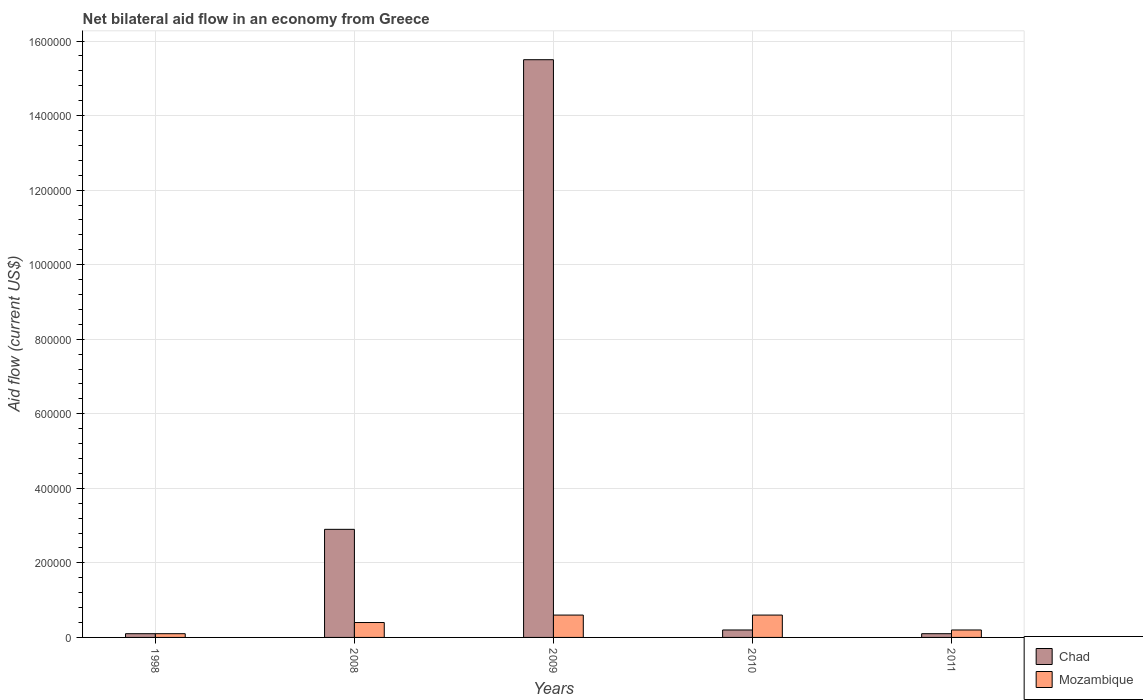How many different coloured bars are there?
Offer a terse response. 2. How many groups of bars are there?
Make the answer very short. 5. Are the number of bars per tick equal to the number of legend labels?
Give a very brief answer. Yes. Are the number of bars on each tick of the X-axis equal?
Provide a succinct answer. Yes. How many bars are there on the 1st tick from the left?
Your answer should be very brief. 2. How many bars are there on the 1st tick from the right?
Provide a succinct answer. 2. What is the label of the 1st group of bars from the left?
Make the answer very short. 1998. In how many cases, is the number of bars for a given year not equal to the number of legend labels?
Ensure brevity in your answer.  0. Across all years, what is the maximum net bilateral aid flow in Mozambique?
Provide a succinct answer. 6.00e+04. Across all years, what is the minimum net bilateral aid flow in Chad?
Offer a terse response. 10000. What is the total net bilateral aid flow in Chad in the graph?
Provide a succinct answer. 1.88e+06. What is the difference between the net bilateral aid flow in Mozambique in 1998 and the net bilateral aid flow in Chad in 2009?
Ensure brevity in your answer.  -1.54e+06. What is the average net bilateral aid flow in Chad per year?
Make the answer very short. 3.76e+05. Is the net bilateral aid flow in Chad in 2010 less than that in 2011?
Offer a very short reply. No. What is the difference between the highest and the second highest net bilateral aid flow in Chad?
Your response must be concise. 1.26e+06. What is the difference between the highest and the lowest net bilateral aid flow in Chad?
Give a very brief answer. 1.54e+06. Is the sum of the net bilateral aid flow in Chad in 1998 and 2011 greater than the maximum net bilateral aid flow in Mozambique across all years?
Your response must be concise. No. What does the 2nd bar from the left in 1998 represents?
Offer a very short reply. Mozambique. What does the 2nd bar from the right in 2010 represents?
Provide a short and direct response. Chad. How many bars are there?
Your answer should be compact. 10. How many years are there in the graph?
Keep it short and to the point. 5. Are the values on the major ticks of Y-axis written in scientific E-notation?
Make the answer very short. No. Does the graph contain any zero values?
Offer a terse response. No. Does the graph contain grids?
Offer a terse response. Yes. Where does the legend appear in the graph?
Give a very brief answer. Bottom right. How many legend labels are there?
Provide a succinct answer. 2. What is the title of the graph?
Provide a succinct answer. Net bilateral aid flow in an economy from Greece. Does "Moldova" appear as one of the legend labels in the graph?
Provide a succinct answer. No. What is the label or title of the Y-axis?
Keep it short and to the point. Aid flow (current US$). What is the Aid flow (current US$) of Chad in 1998?
Ensure brevity in your answer.  10000. What is the Aid flow (current US$) in Mozambique in 1998?
Make the answer very short. 10000. What is the Aid flow (current US$) in Chad in 2008?
Give a very brief answer. 2.90e+05. What is the Aid flow (current US$) of Mozambique in 2008?
Make the answer very short. 4.00e+04. What is the Aid flow (current US$) in Chad in 2009?
Your answer should be compact. 1.55e+06. What is the Aid flow (current US$) in Mozambique in 2009?
Give a very brief answer. 6.00e+04. What is the Aid flow (current US$) in Mozambique in 2011?
Your answer should be compact. 2.00e+04. Across all years, what is the maximum Aid flow (current US$) in Chad?
Your answer should be compact. 1.55e+06. Across all years, what is the maximum Aid flow (current US$) of Mozambique?
Provide a succinct answer. 6.00e+04. Across all years, what is the minimum Aid flow (current US$) in Chad?
Make the answer very short. 10000. What is the total Aid flow (current US$) in Chad in the graph?
Make the answer very short. 1.88e+06. What is the difference between the Aid flow (current US$) in Chad in 1998 and that in 2008?
Provide a succinct answer. -2.80e+05. What is the difference between the Aid flow (current US$) of Chad in 1998 and that in 2009?
Offer a very short reply. -1.54e+06. What is the difference between the Aid flow (current US$) in Mozambique in 1998 and that in 2009?
Offer a terse response. -5.00e+04. What is the difference between the Aid flow (current US$) in Chad in 1998 and that in 2010?
Give a very brief answer. -10000. What is the difference between the Aid flow (current US$) of Mozambique in 1998 and that in 2010?
Provide a short and direct response. -5.00e+04. What is the difference between the Aid flow (current US$) of Mozambique in 1998 and that in 2011?
Keep it short and to the point. -10000. What is the difference between the Aid flow (current US$) in Chad in 2008 and that in 2009?
Your response must be concise. -1.26e+06. What is the difference between the Aid flow (current US$) of Mozambique in 2008 and that in 2009?
Provide a short and direct response. -2.00e+04. What is the difference between the Aid flow (current US$) in Chad in 2008 and that in 2010?
Your answer should be very brief. 2.70e+05. What is the difference between the Aid flow (current US$) of Mozambique in 2008 and that in 2010?
Your response must be concise. -2.00e+04. What is the difference between the Aid flow (current US$) in Chad in 2008 and that in 2011?
Keep it short and to the point. 2.80e+05. What is the difference between the Aid flow (current US$) in Chad in 2009 and that in 2010?
Your response must be concise. 1.53e+06. What is the difference between the Aid flow (current US$) of Mozambique in 2009 and that in 2010?
Ensure brevity in your answer.  0. What is the difference between the Aid flow (current US$) of Chad in 2009 and that in 2011?
Ensure brevity in your answer.  1.54e+06. What is the difference between the Aid flow (current US$) in Chad in 2010 and that in 2011?
Provide a succinct answer. 10000. What is the difference between the Aid flow (current US$) in Chad in 1998 and the Aid flow (current US$) in Mozambique in 2009?
Offer a terse response. -5.00e+04. What is the difference between the Aid flow (current US$) of Chad in 1998 and the Aid flow (current US$) of Mozambique in 2010?
Give a very brief answer. -5.00e+04. What is the difference between the Aid flow (current US$) in Chad in 1998 and the Aid flow (current US$) in Mozambique in 2011?
Ensure brevity in your answer.  -10000. What is the difference between the Aid flow (current US$) of Chad in 2008 and the Aid flow (current US$) of Mozambique in 2009?
Your answer should be compact. 2.30e+05. What is the difference between the Aid flow (current US$) in Chad in 2008 and the Aid flow (current US$) in Mozambique in 2010?
Make the answer very short. 2.30e+05. What is the difference between the Aid flow (current US$) in Chad in 2009 and the Aid flow (current US$) in Mozambique in 2010?
Provide a succinct answer. 1.49e+06. What is the difference between the Aid flow (current US$) in Chad in 2009 and the Aid flow (current US$) in Mozambique in 2011?
Your answer should be compact. 1.53e+06. What is the average Aid flow (current US$) of Chad per year?
Ensure brevity in your answer.  3.76e+05. What is the average Aid flow (current US$) of Mozambique per year?
Your response must be concise. 3.80e+04. In the year 1998, what is the difference between the Aid flow (current US$) of Chad and Aid flow (current US$) of Mozambique?
Offer a very short reply. 0. In the year 2008, what is the difference between the Aid flow (current US$) in Chad and Aid flow (current US$) in Mozambique?
Offer a very short reply. 2.50e+05. In the year 2009, what is the difference between the Aid flow (current US$) in Chad and Aid flow (current US$) in Mozambique?
Your response must be concise. 1.49e+06. In the year 2010, what is the difference between the Aid flow (current US$) of Chad and Aid flow (current US$) of Mozambique?
Provide a succinct answer. -4.00e+04. In the year 2011, what is the difference between the Aid flow (current US$) of Chad and Aid flow (current US$) of Mozambique?
Provide a succinct answer. -10000. What is the ratio of the Aid flow (current US$) in Chad in 1998 to that in 2008?
Your answer should be compact. 0.03. What is the ratio of the Aid flow (current US$) of Chad in 1998 to that in 2009?
Ensure brevity in your answer.  0.01. What is the ratio of the Aid flow (current US$) in Chad in 1998 to that in 2010?
Offer a very short reply. 0.5. What is the ratio of the Aid flow (current US$) in Chad in 2008 to that in 2009?
Offer a very short reply. 0.19. What is the ratio of the Aid flow (current US$) in Chad in 2008 to that in 2010?
Your response must be concise. 14.5. What is the ratio of the Aid flow (current US$) in Mozambique in 2008 to that in 2011?
Offer a terse response. 2. What is the ratio of the Aid flow (current US$) of Chad in 2009 to that in 2010?
Your response must be concise. 77.5. What is the ratio of the Aid flow (current US$) of Mozambique in 2009 to that in 2010?
Offer a terse response. 1. What is the ratio of the Aid flow (current US$) in Chad in 2009 to that in 2011?
Offer a terse response. 155. What is the difference between the highest and the second highest Aid flow (current US$) of Chad?
Make the answer very short. 1.26e+06. What is the difference between the highest and the second highest Aid flow (current US$) of Mozambique?
Offer a very short reply. 0. What is the difference between the highest and the lowest Aid flow (current US$) in Chad?
Your answer should be very brief. 1.54e+06. What is the difference between the highest and the lowest Aid flow (current US$) of Mozambique?
Your answer should be compact. 5.00e+04. 